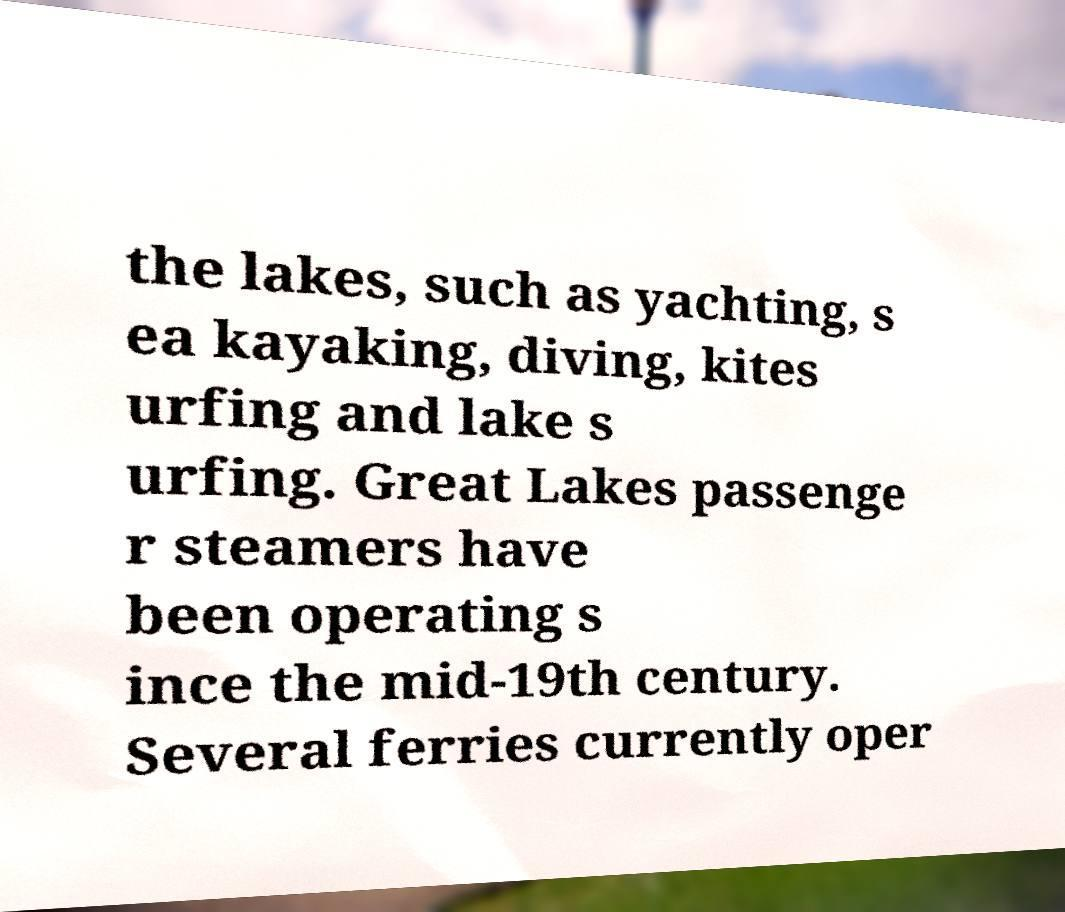I need the written content from this picture converted into text. Can you do that? the lakes, such as yachting, s ea kayaking, diving, kites urfing and lake s urfing. Great Lakes passenge r steamers have been operating s ince the mid-19th century. Several ferries currently oper 